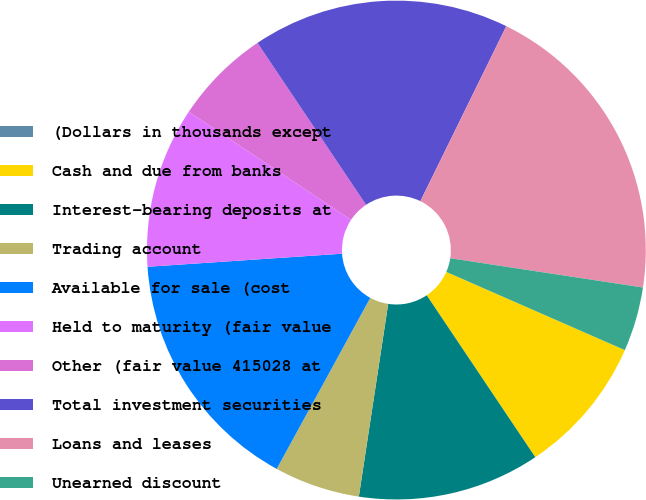Convert chart to OTSL. <chart><loc_0><loc_0><loc_500><loc_500><pie_chart><fcel>(Dollars in thousands except<fcel>Cash and due from banks<fcel>Interest-bearing deposits at<fcel>Trading account<fcel>Available for sale (cost<fcel>Held to maturity (fair value<fcel>Other (fair value 415028 at<fcel>Total investment securities<fcel>Loans and leases<fcel>Unearned discount<nl><fcel>0.0%<fcel>9.03%<fcel>11.81%<fcel>5.56%<fcel>15.97%<fcel>10.42%<fcel>6.25%<fcel>16.67%<fcel>20.14%<fcel>4.17%<nl></chart> 